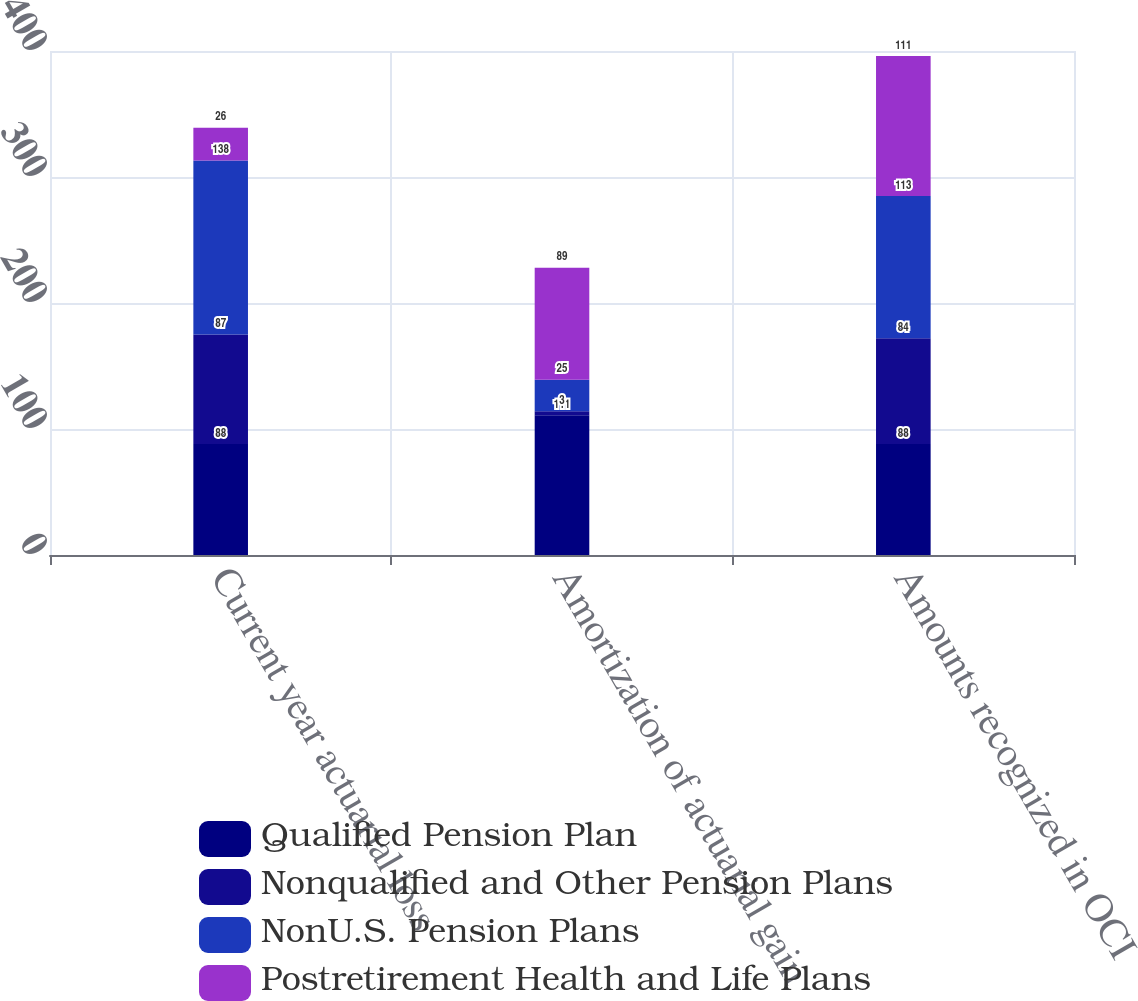Convert chart. <chart><loc_0><loc_0><loc_500><loc_500><stacked_bar_chart><ecel><fcel>Current year actuarial loss<fcel>Amortization of actuarial gain<fcel>Amounts recognized in OCI<nl><fcel>Qualified Pension Plan<fcel>88<fcel>111<fcel>88<nl><fcel>Nonqualified and Other Pension Plans<fcel>87<fcel>3<fcel>84<nl><fcel>NonU.S. Pension Plans<fcel>138<fcel>25<fcel>113<nl><fcel>Postretirement Health and Life Plans<fcel>26<fcel>89<fcel>111<nl></chart> 